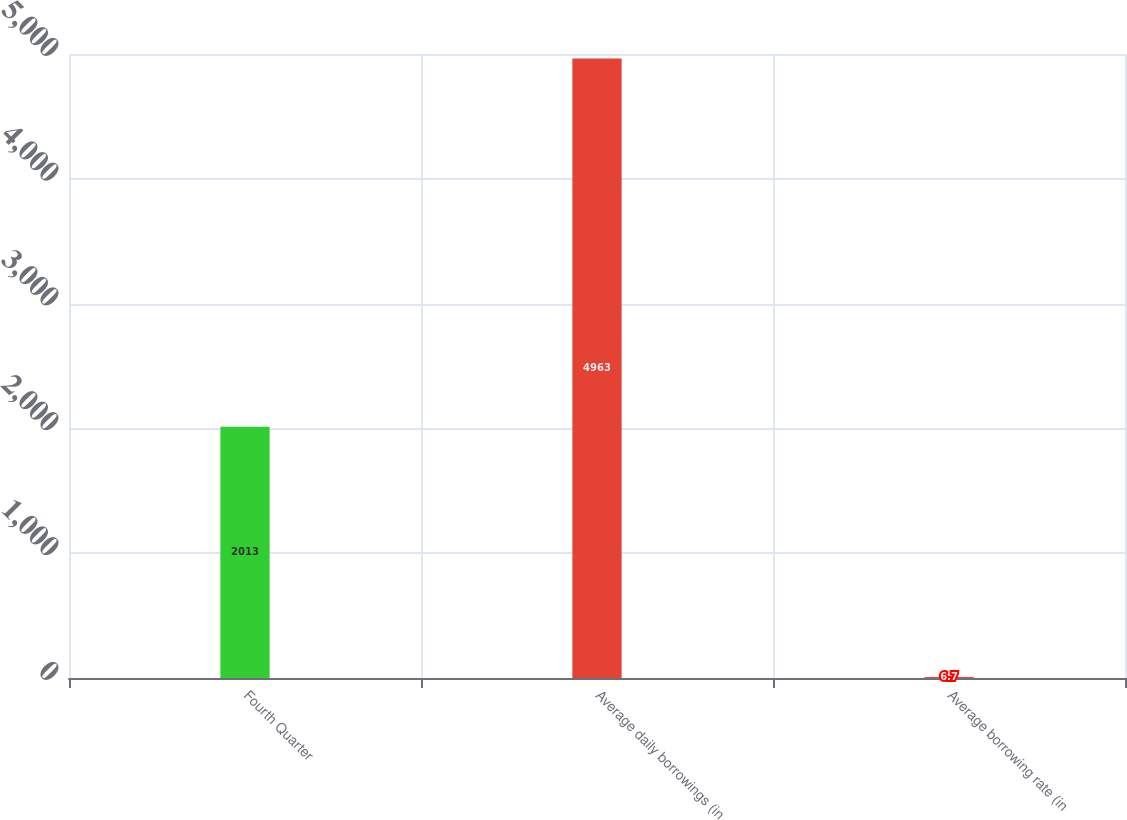<chart> <loc_0><loc_0><loc_500><loc_500><bar_chart><fcel>Fourth Quarter<fcel>Average daily borrowings (in<fcel>Average borrowing rate (in<nl><fcel>2013<fcel>4963<fcel>6.7<nl></chart> 